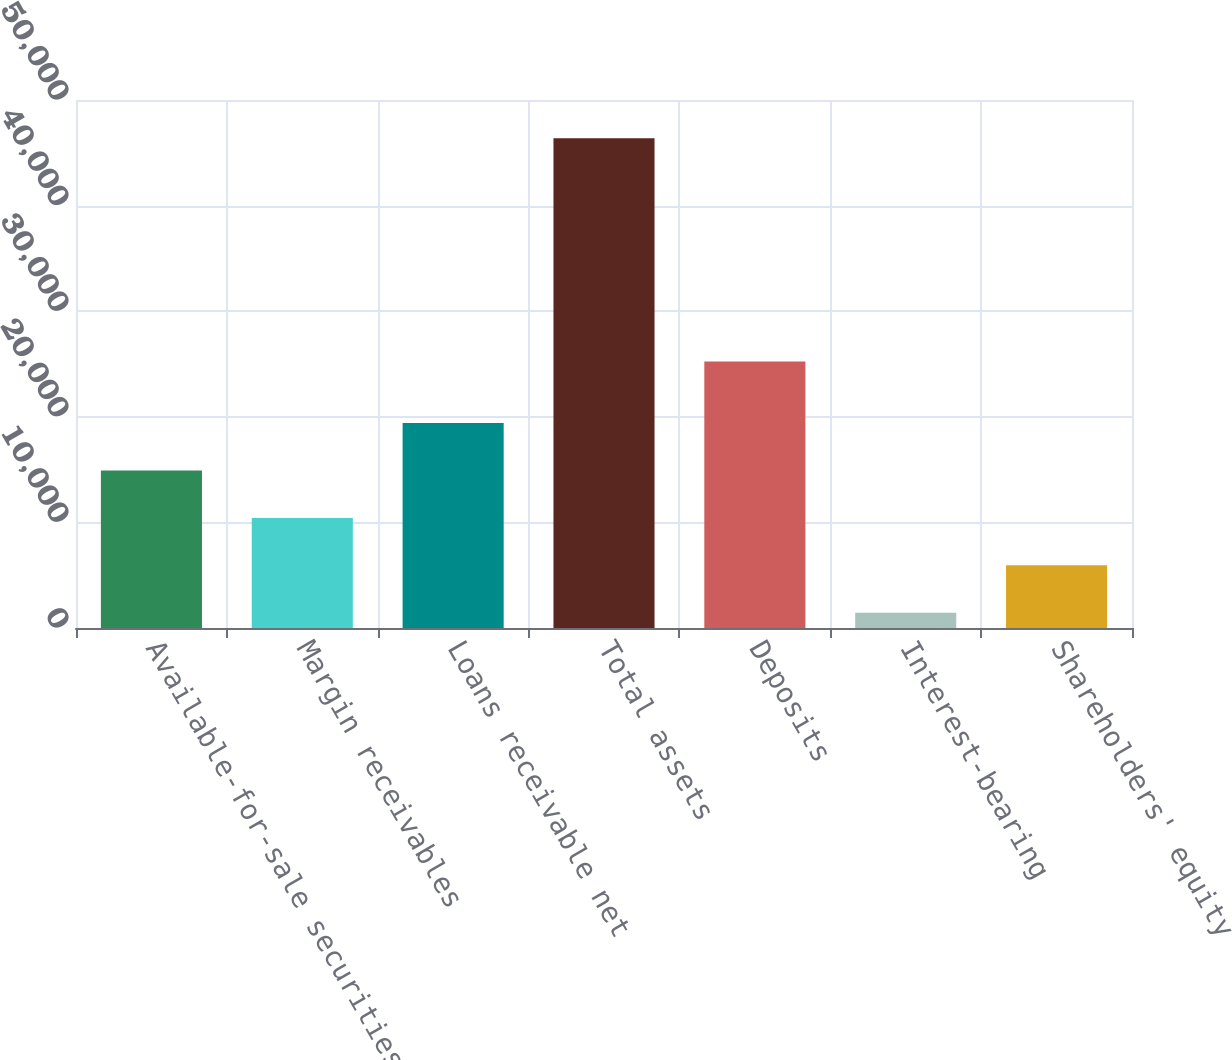Convert chart to OTSL. <chart><loc_0><loc_0><loc_500><loc_500><bar_chart><fcel>Available-for-sale securities<fcel>Margin receivables<fcel>Loans receivable net<fcel>Total assets<fcel>Deposits<fcel>Interest-bearing<fcel>Shareholders' equity<nl><fcel>14921.2<fcel>10428.1<fcel>19414.3<fcel>46373<fcel>25240.3<fcel>1441.9<fcel>5935.01<nl></chart> 